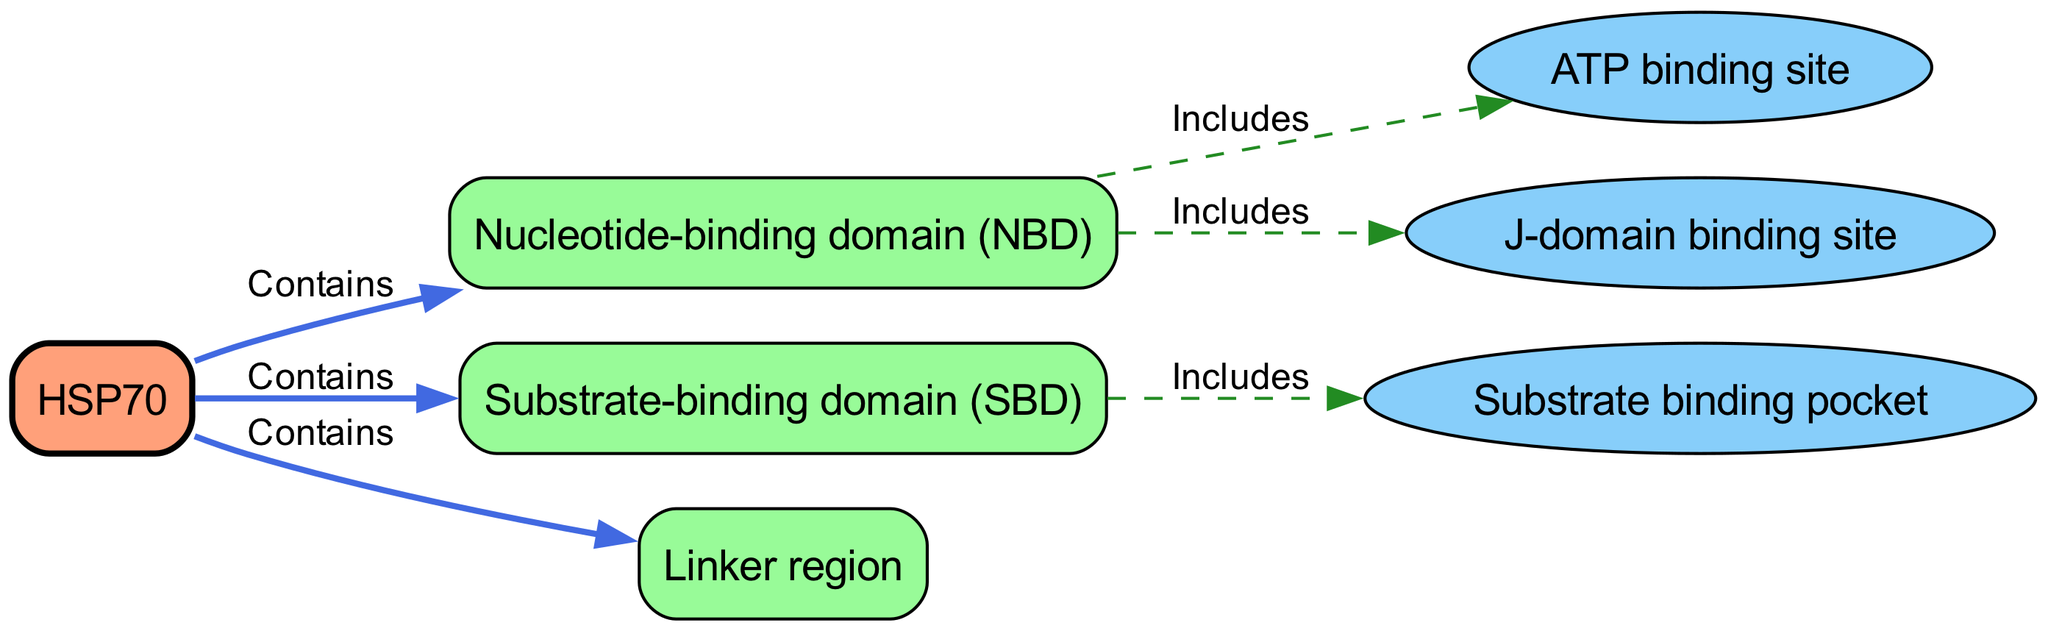What is the main protein represented in the diagram? The diagram clearly identifies HSP70 as the central protein node. It is the only protein node in the diagram, and labeled directly.
Answer: HSP70 How many domains are present in HSP70? The diagram contains three domain nodes connected to the HSP70 protein node: Nucleotide-binding domain, Substrate-binding domain, and Linker region. Counting these gives a total of three domains.
Answer: 3 What type of site does the Nucleotide-binding domain include? The Nucleotide-binding domain directly includes the ATP binding site as indicated by the dashed edge connecting these nodes. Therefore, it is recognized as a binding site type.
Answer: ATP binding site Which domain is associated with the substrate binding pocket? The Substrate-binding domain is directly linked to the substrate binding pocket through an edge labeled "Includes". This relationship indicates that the SBD is associated with this particular binding pocket.
Answer: Substrate-binding pocket What is the relationship between HSP70 and the Linker region? HSP70 has a "Contains" relationship with the Linker region, indicating that the Linker region is a part of the overall structure and function of the HSP70 protein.
Answer: Contains How many binding sites are included across all domains? By analyzing the diagram, there are three binding sites illustrated: ATP binding site, Substrate binding pocket, and J-domain binding site. Counting these gives a total of three binding sites.
Answer: 3 What type of edge connects the Nucleotide-binding domain and the J-domain binding site? The edge connecting these two specifically labeled nodes is identified as "Includes", indicating that the J-domain binding site is a component of the Nucleotide-binding domain.
Answer: Includes What color represents the domains in the diagram? The domains in the diagram are represented in green, which is evident from the fill color designated for domain nodes.
Answer: Green 